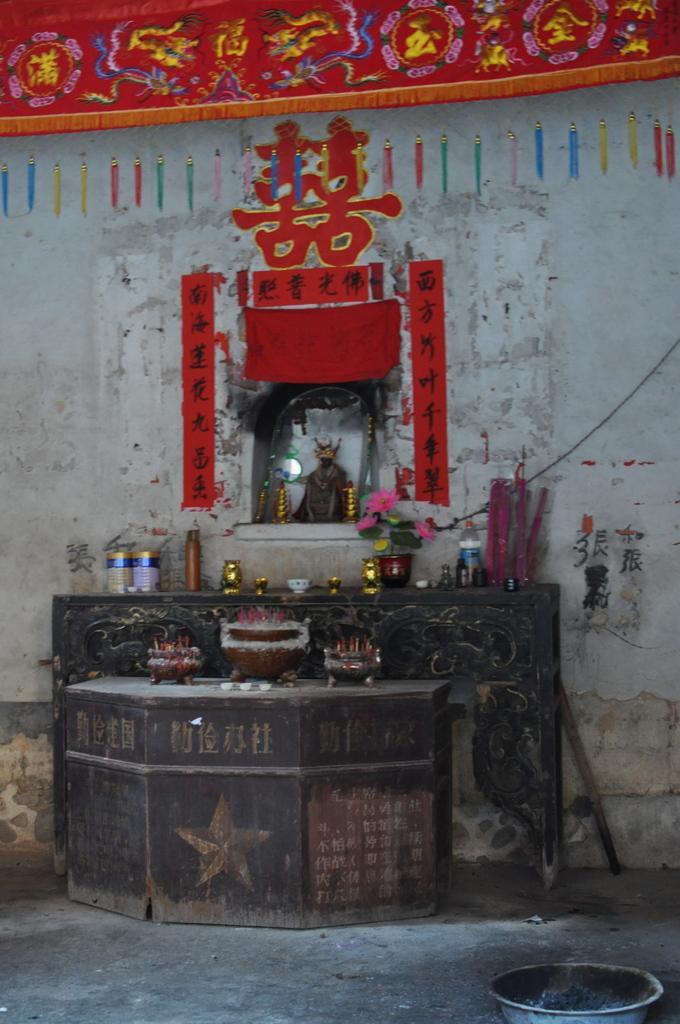In one or two sentences, can you explain what this image depicts? In this image we can see some text and clothes on the wall, there are some objects on the table, there is a bowl. 